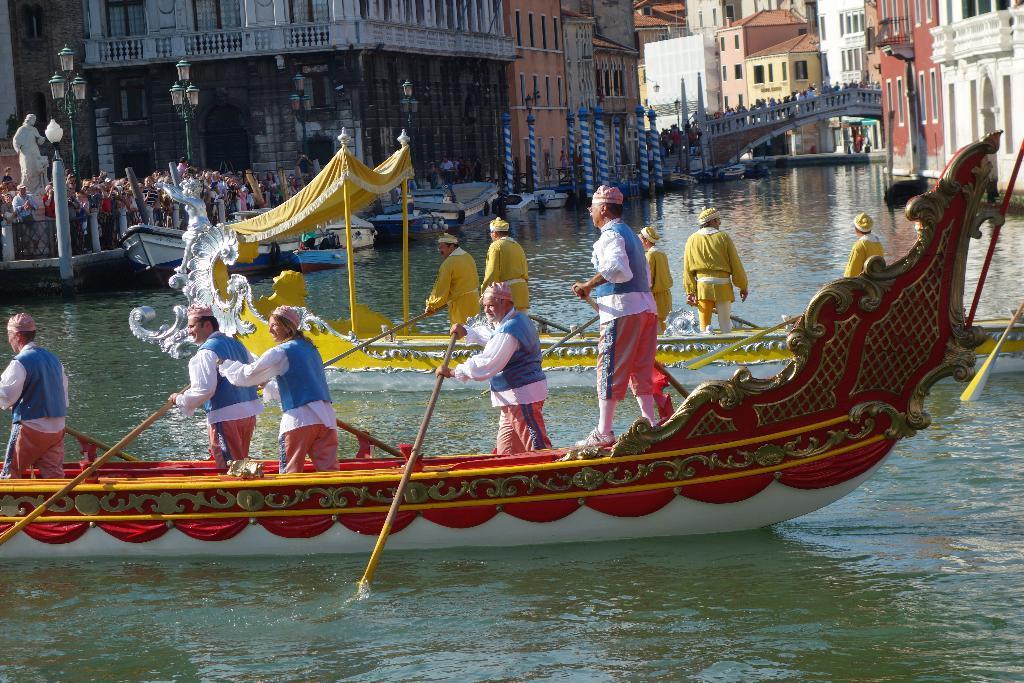Please provide a concise description of this image. In this image, we can see few people are sailing boats on the water. Few are holding an object. Top of the image, we can see so many buildings, street lights, poles, walls, windows, railings, bridge, statue and a group of people. 